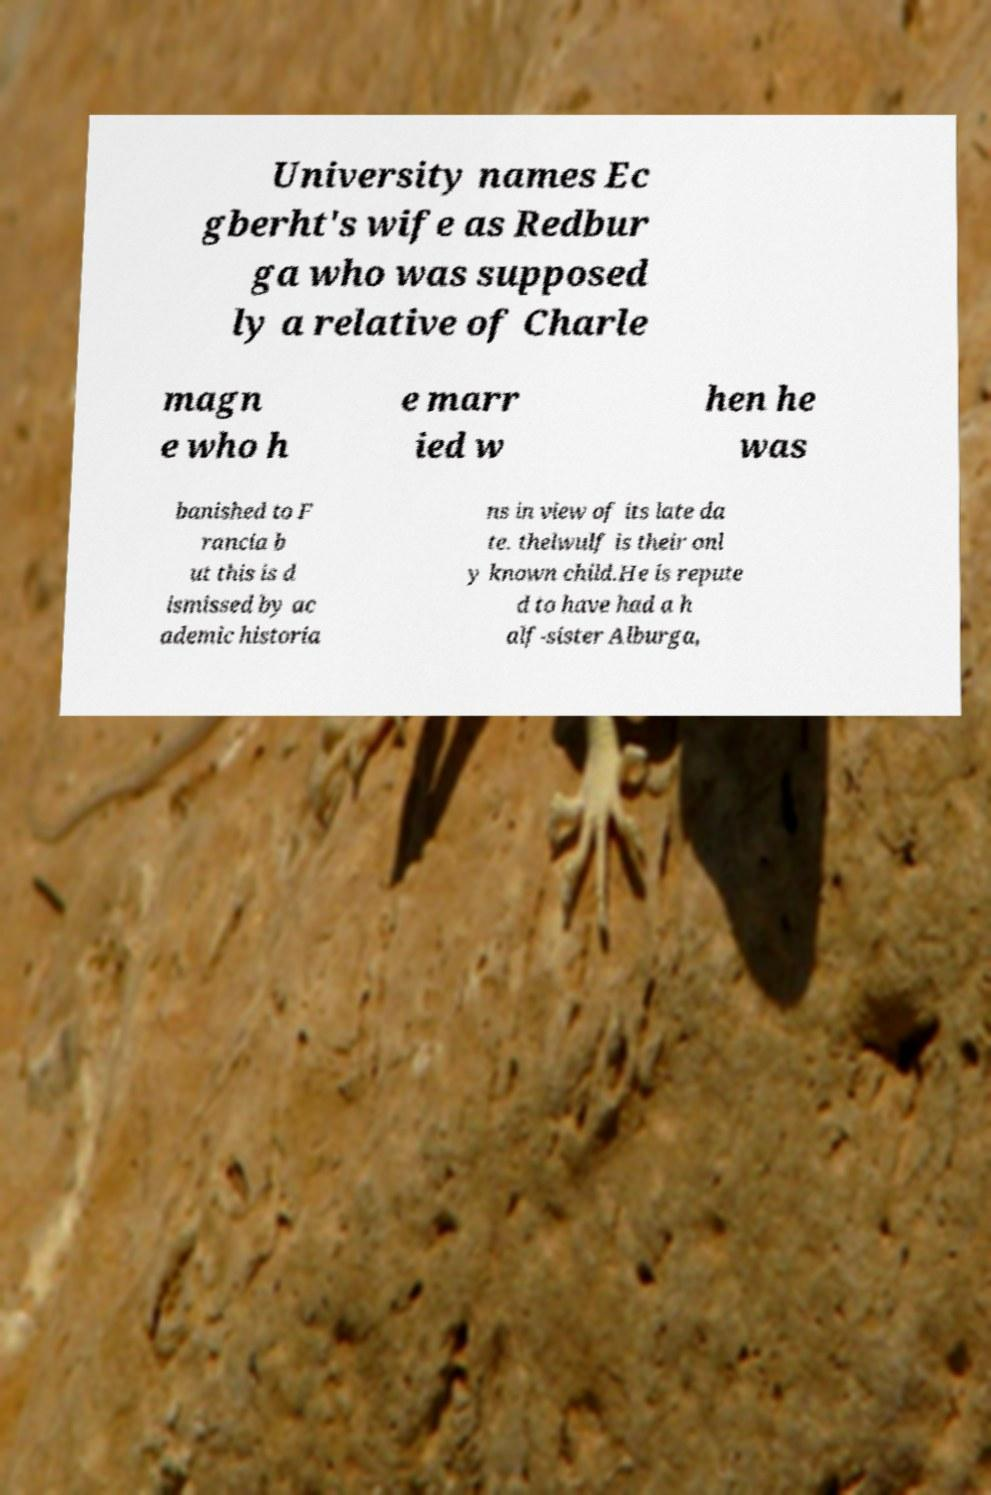There's text embedded in this image that I need extracted. Can you transcribe it verbatim? University names Ec gberht's wife as Redbur ga who was supposed ly a relative of Charle magn e who h e marr ied w hen he was banished to F rancia b ut this is d ismissed by ac ademic historia ns in view of its late da te. thelwulf is their onl y known child.He is repute d to have had a h alf-sister Alburga, 